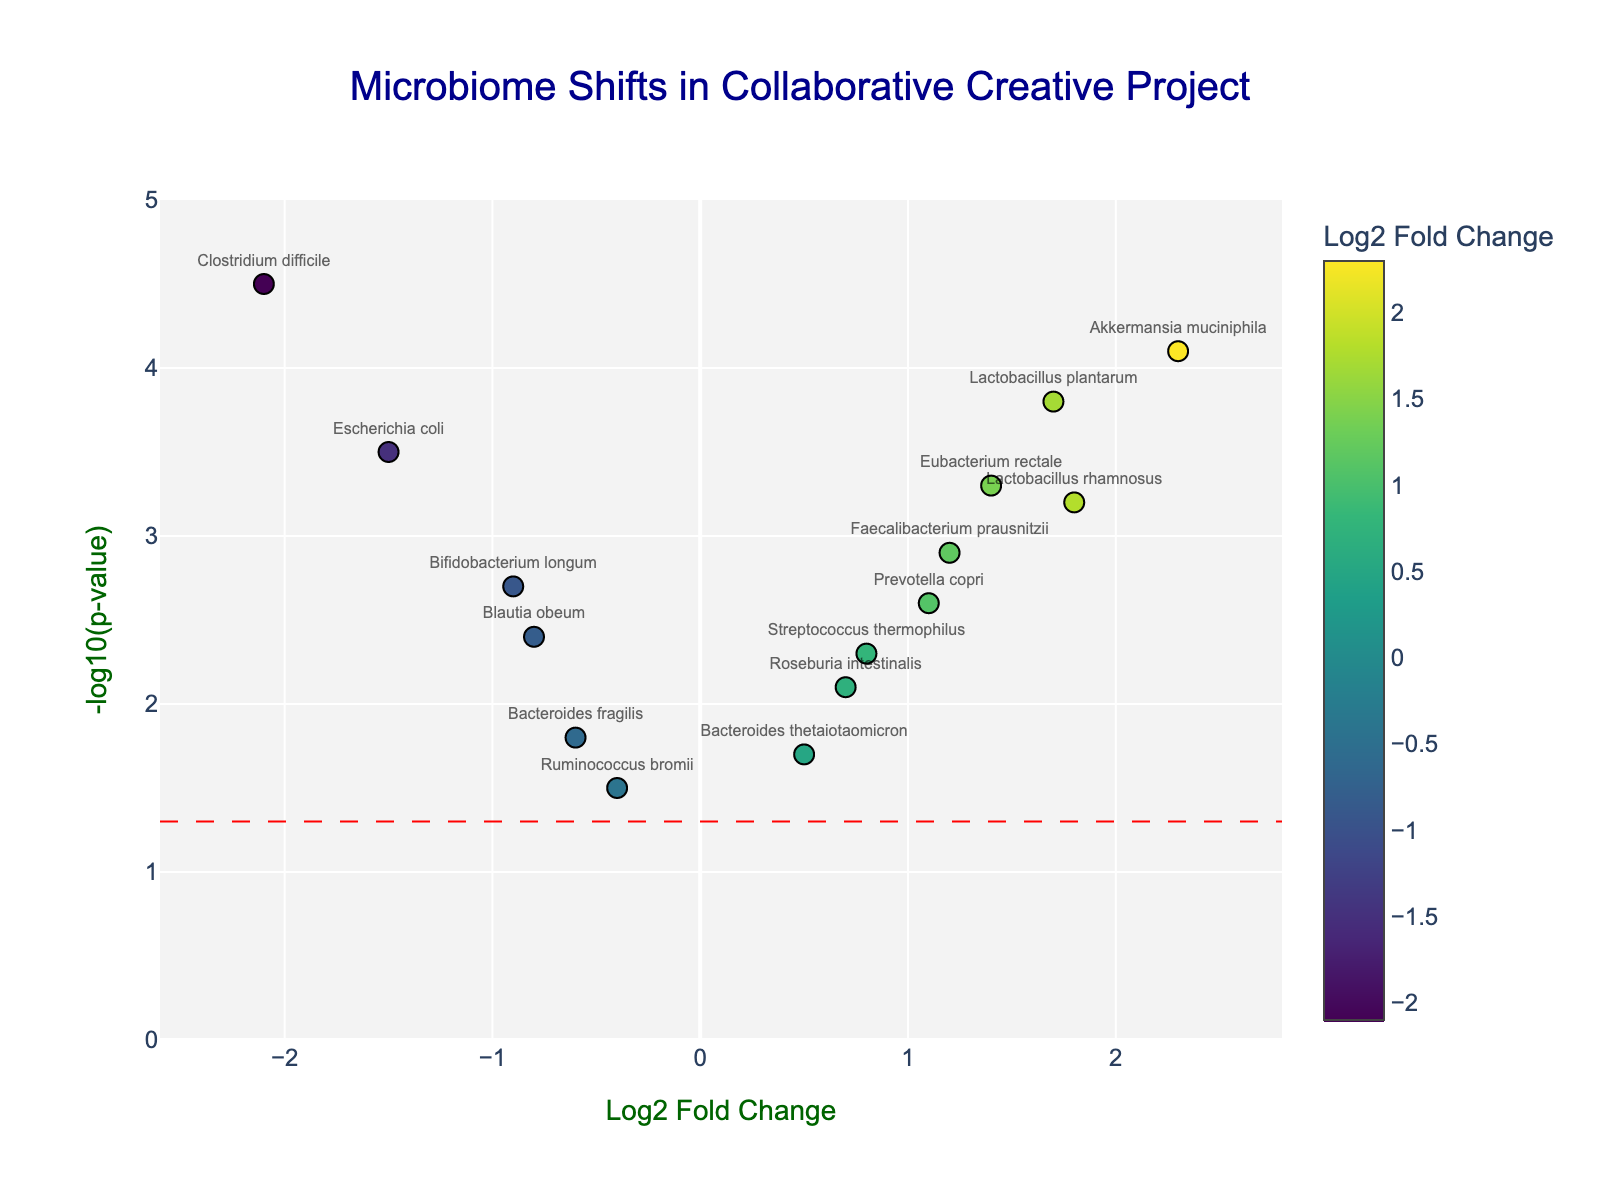How many bacteria are represented in the figure? Count the number of different bacteria labeled on the plot.
Answer: 15 Which bacteria shows the highest Log2 Fold Change? Identify the data point with the highest x-value on the plot.
Answer: Akkermansia muciniphila What is the significance threshold line's y-value? Look at the y-axis value where the red dashed line is positioned.
Answer: 1.301 Which bacteria has the lowest Negative Log P-value? Identify the data point with the lowest y-value on the plot.
Answer: Ruminococcus bromii Which bacteria has a Log2 Fold Change closest to zero and what is its Negative Log P-value? Look for the point on the plot that is closest to the zero x-axis, which represents Log2 Fold Change, and provide its y-axis value.
Answer: Bacteroides thetaiotaomicron has a Negative Log P-value of 1.7 What is the Log2 Fold Change of Escherichia coli and is it negative or positive? Find Escherichia coli on the plot and read its x-value to determine its Log2 Fold Change and sign.
Answer: -1.5, negative How many bacteria have Log2 Fold Changes greater than 1? Count the number of bacteria on the plot with x-values greater than 1.
Answer: 5 Compare the Negative Log P-values of Clostridium difficile and Akkermansia muciniphila. Which is higher? Find and compare the y-values of Clostridium difficile and Akkermansia muciniphila on the plot.
Answer: Clostridium difficile Which bacteria has the lowest Log2 Fold Change and what is its Negative Log P-value? Identify the data point with the lowest x-value and provide its y-value.
Answer: Clostridium difficile has a Negative Log P-value of 4.5 Which bacteria associated with mood and cognitive function shows the greatest increase in abundance after the creative project? Identify the bacteria on the plot with the highest positive Log2 Fold Change.
Answer: Akkermansia muciniphila 